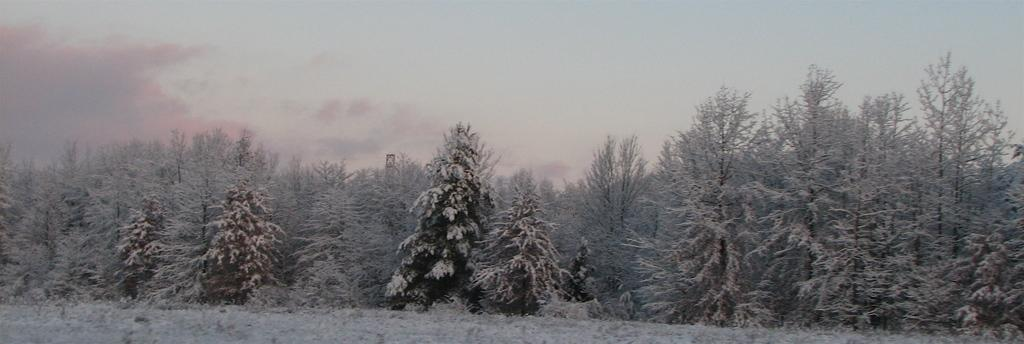What type of vegetation can be seen in the image? There are trees in the image. What is covering the trees in the image? The trees are covered with snow. What is visible at the top of the image? The sky is visible at the top of the image. What type of sand can be seen covering the trees in the image? There is no sand present in the image; the trees are covered with snow. How does the sleet affect the visibility of the trees in the image? There is no mention of sleet in the image; the trees are covered with snow. 